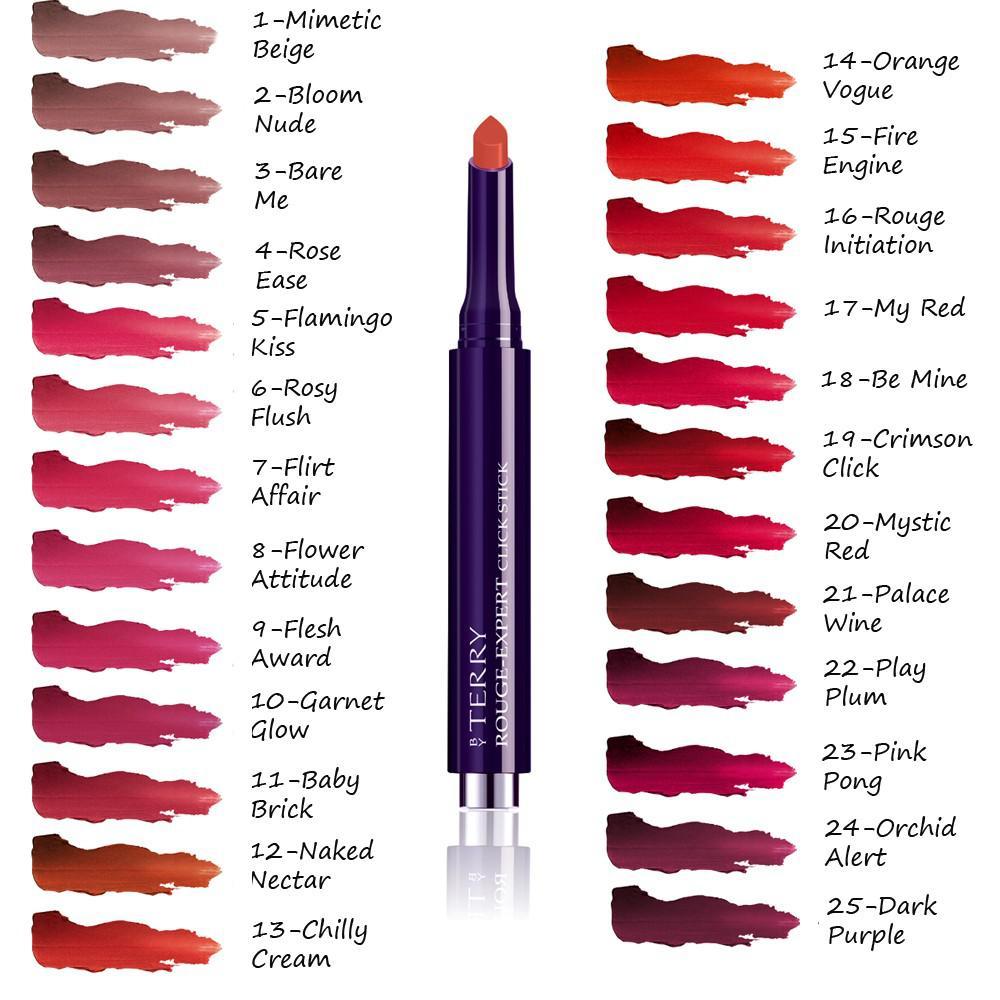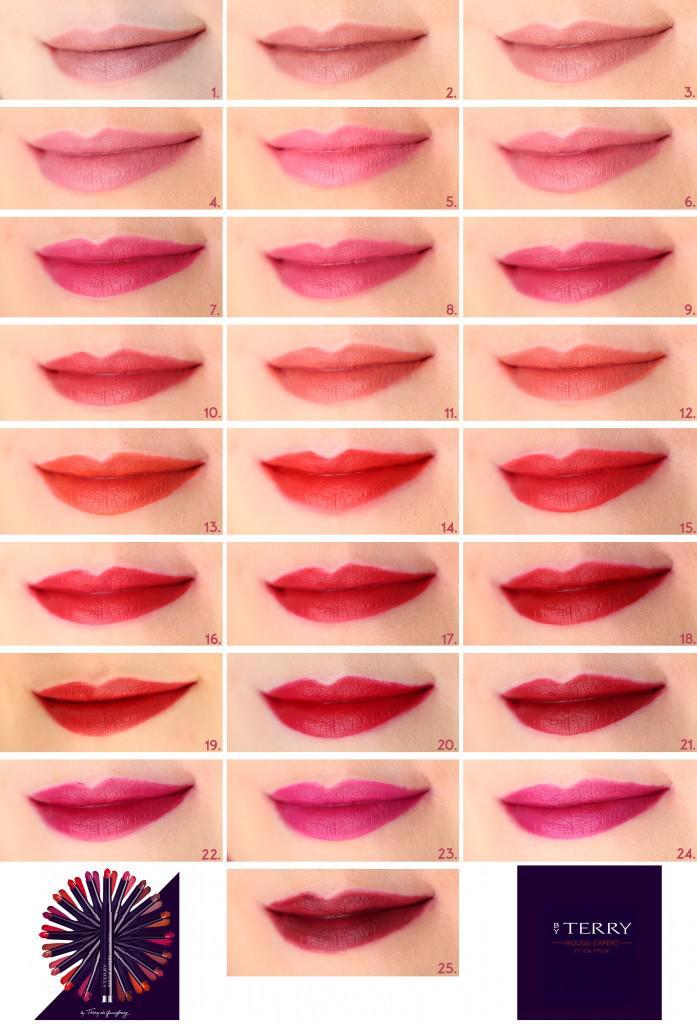The first image is the image on the left, the second image is the image on the right. For the images shown, is this caption "An image shows smears of lipstick across at least one inner arm." true? Answer yes or no. No. The first image is the image on the left, the second image is the image on the right. Evaluate the accuracy of this statement regarding the images: "One of the images shows different shades of lipstick on human arm.". Is it true? Answer yes or no. No. 